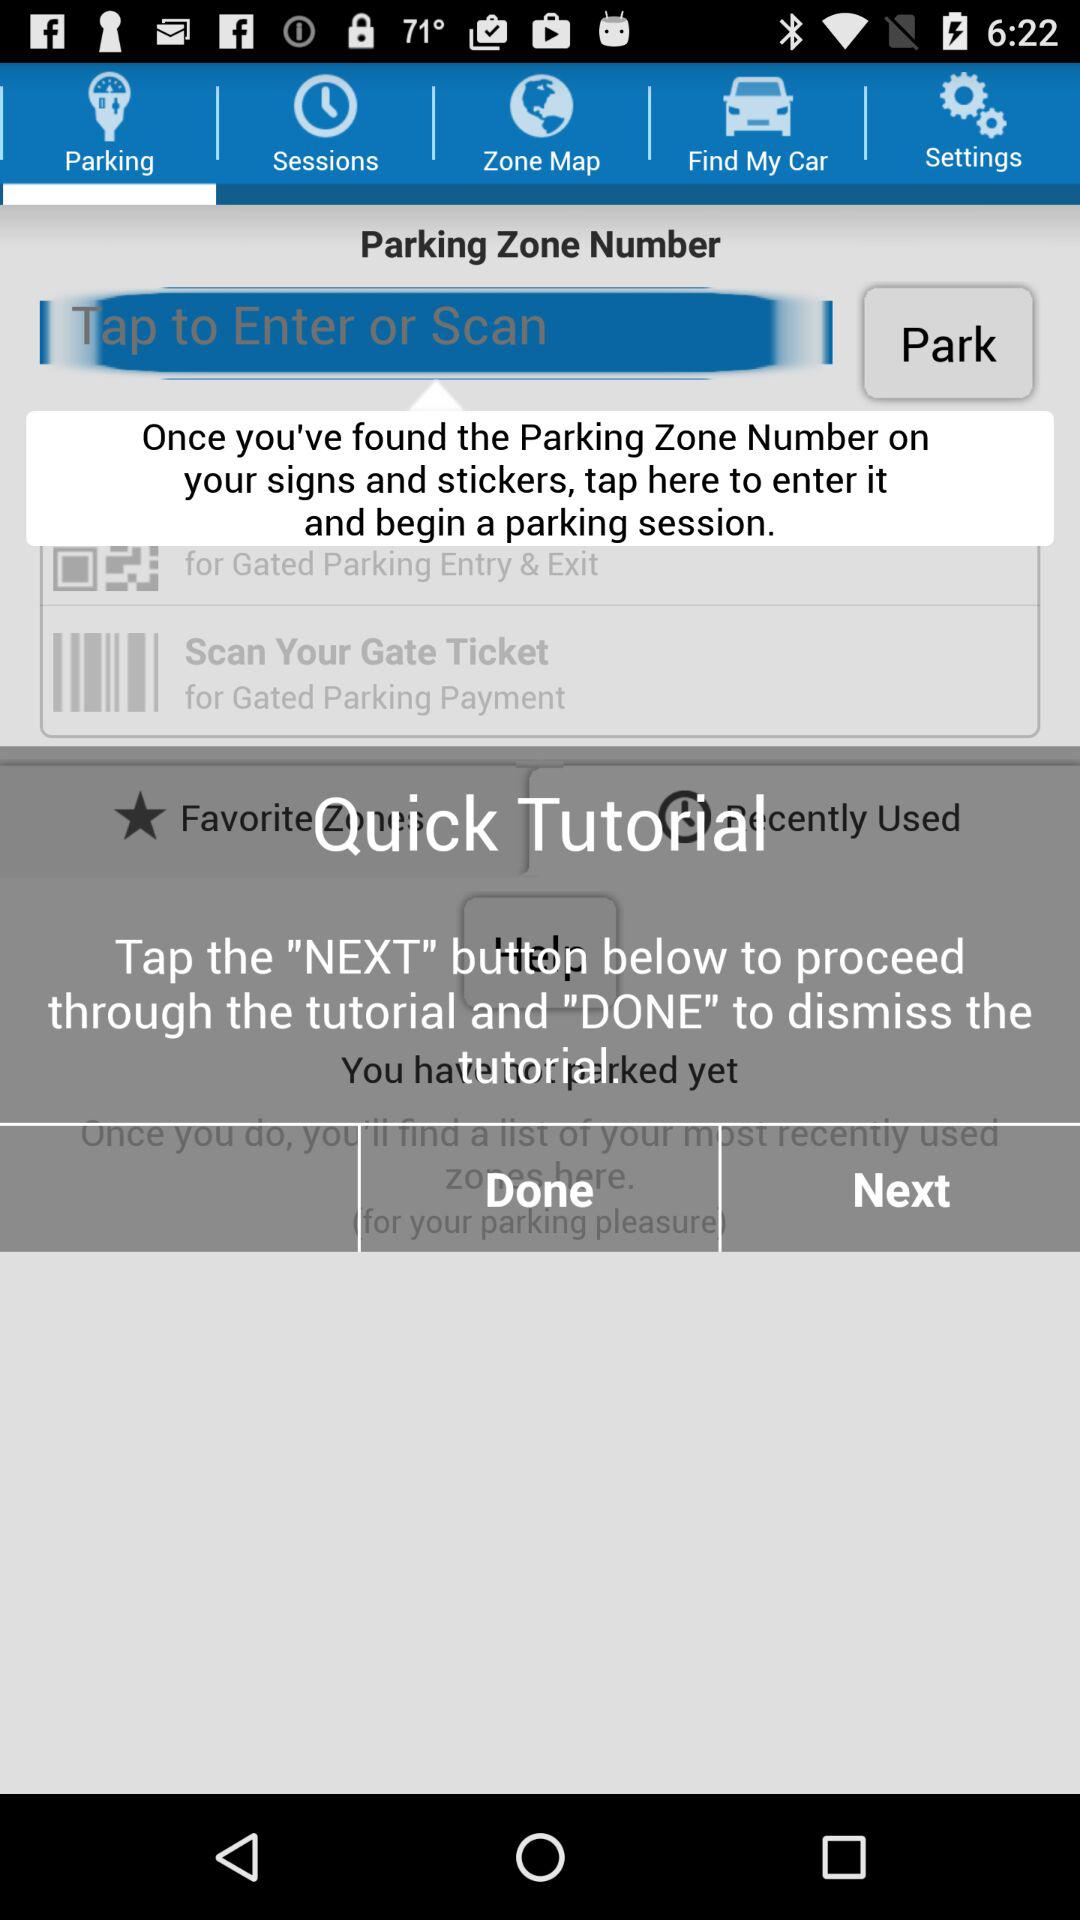What is the use of the "NEXT" button? The "NEXT" button is used to proceed through the tutorial. 